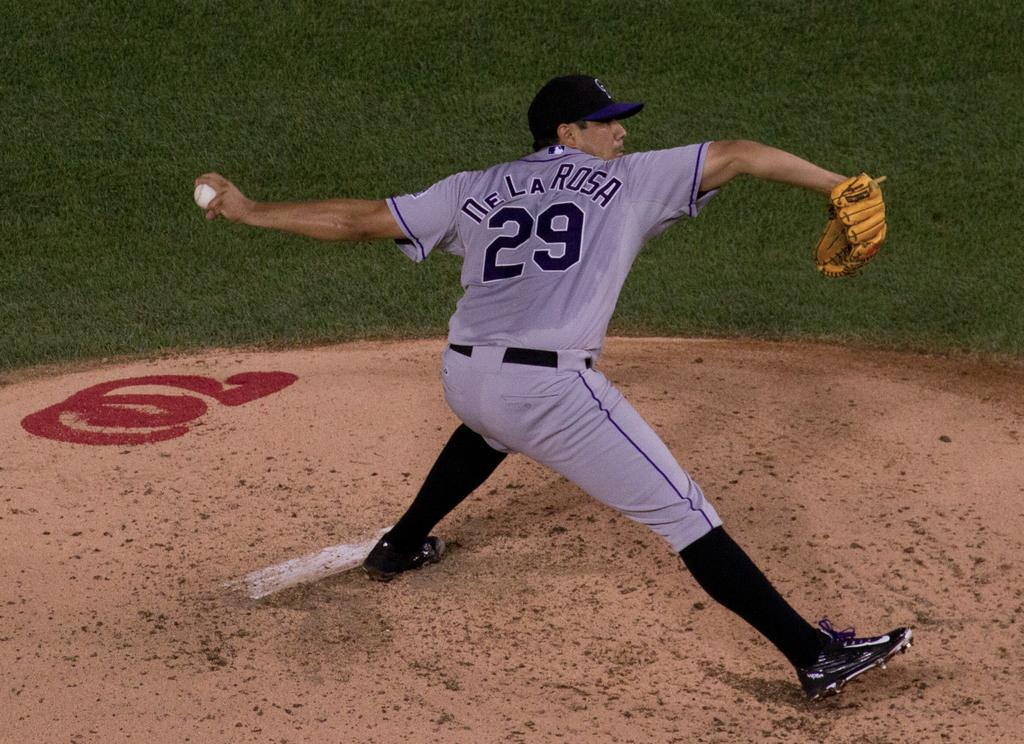<image>
Write a terse but informative summary of the picture. number 29 DeLa Rosa pitcher ready to throw the ball 